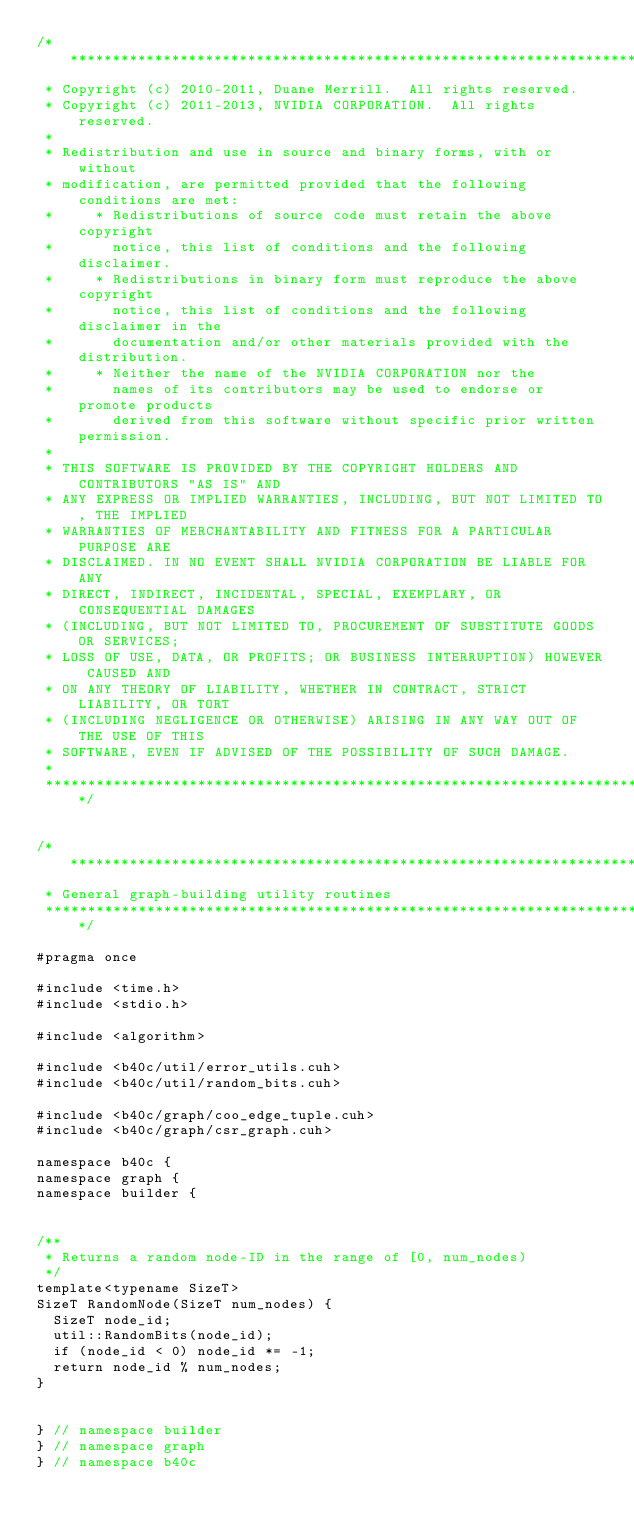<code> <loc_0><loc_0><loc_500><loc_500><_Cuda_>/******************************************************************************
 * Copyright (c) 2010-2011, Duane Merrill.  All rights reserved.
 * Copyright (c) 2011-2013, NVIDIA CORPORATION.  All rights reserved.
 * 
 * Redistribution and use in source and binary forms, with or without
 * modification, are permitted provided that the following conditions are met:
 *     * Redistributions of source code must retain the above copyright
 *       notice, this list of conditions and the following disclaimer.
 *     * Redistributions in binary form must reproduce the above copyright
 *       notice, this list of conditions and the following disclaimer in the
 *       documentation and/or other materials provided with the distribution.
 *     * Neither the name of the NVIDIA CORPORATION nor the
 *       names of its contributors may be used to endorse or promote products
 *       derived from this software without specific prior written permission.
 * 
 * THIS SOFTWARE IS PROVIDED BY THE COPYRIGHT HOLDERS AND CONTRIBUTORS "AS IS" AND
 * ANY EXPRESS OR IMPLIED WARRANTIES, INCLUDING, BUT NOT LIMITED TO, THE IMPLIED
 * WARRANTIES OF MERCHANTABILITY AND FITNESS FOR A PARTICULAR PURPOSE ARE
 * DISCLAIMED. IN NO EVENT SHALL NVIDIA CORPORATION BE LIABLE FOR ANY
 * DIRECT, INDIRECT, INCIDENTAL, SPECIAL, EXEMPLARY, OR CONSEQUENTIAL DAMAGES
 * (INCLUDING, BUT NOT LIMITED TO, PROCUREMENT OF SUBSTITUTE GOODS OR SERVICES;
 * LOSS OF USE, DATA, OR PROFITS; OR BUSINESS INTERRUPTION) HOWEVER CAUSED AND
 * ON ANY THEORY OF LIABILITY, WHETHER IN CONTRACT, STRICT LIABILITY, OR TORT
 * (INCLUDING NEGLIGENCE OR OTHERWISE) ARISING IN ANY WAY OUT OF THE USE OF THIS
 * SOFTWARE, EVEN IF ADVISED OF THE POSSIBILITY OF SUCH DAMAGE.
 *
 ******************************************************************************/


/******************************************************************************
 * General graph-building utility routines
 ******************************************************************************/

#pragma once

#include <time.h>
#include <stdio.h>

#include <algorithm>

#include <b40c/util/error_utils.cuh>
#include <b40c/util/random_bits.cuh>

#include <b40c/graph/coo_edge_tuple.cuh>
#include <b40c/graph/csr_graph.cuh>

namespace b40c {
namespace graph {
namespace builder {


/**
 * Returns a random node-ID in the range of [0, num_nodes) 
 */
template<typename SizeT>
SizeT RandomNode(SizeT num_nodes) {
	SizeT node_id;
	util::RandomBits(node_id);
	if (node_id < 0) node_id *= -1;
	return node_id % num_nodes;
}


} // namespace builder
} // namespace graph
} // namespace b40c
</code> 